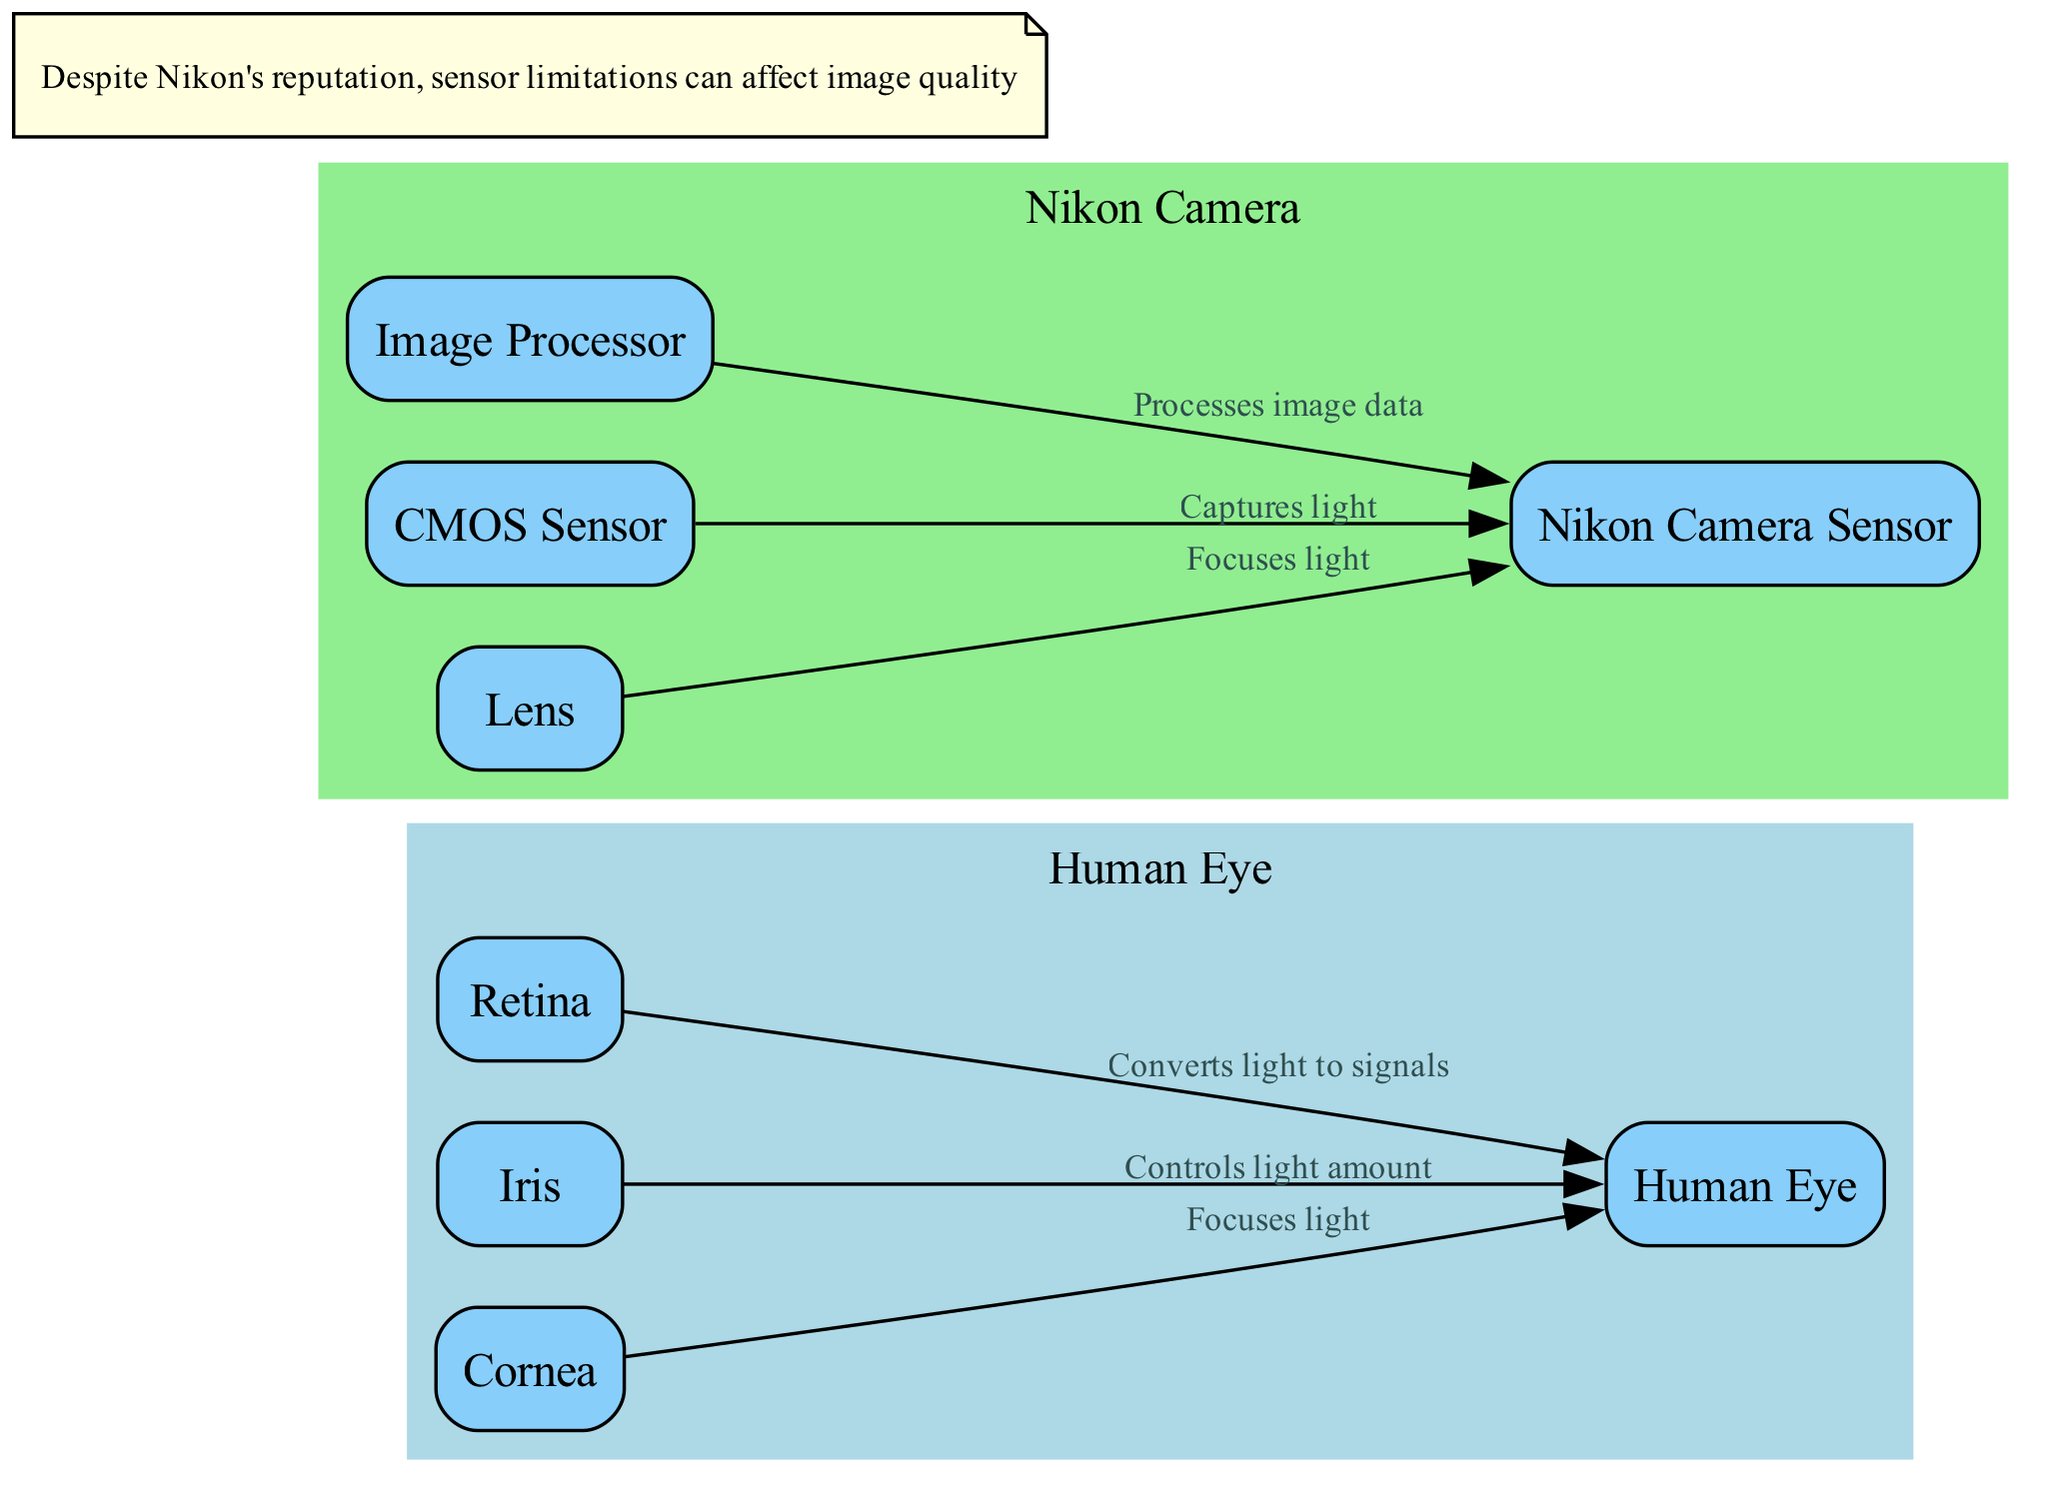What node controls the amount of light entering the eye? The diagram indicates that the "Iris" node is responsible for controlling the amount of light that enters the eye. This can be found by examining the direct connection from the "Iris" to the "Human Eye" node, where the edge explicitly states its function.
Answer: Iris How many nodes represent parts of the Nikon camera system? By counting the nodes listed within the "Nikon Camera" subgraph, we find that there are four distinct nodes: "Nikon Camera Sensor," "Lens," "CMOS Sensor," and "Image Processor." Therefore, the total number of camera system parts represented is four.
Answer: 4 What is the role of the Retina in the human eye? The diagram illustrates that the "Retina" converts light to signals. This is evident from the edge connecting the "Retina" to the "Human Eye," where the label clearly describes this function.
Answer: Converts light to signals Which part focuses light for both the eye and camera? The explanation requires identifying both "Cornea" for the eye and "Lens" for the camera, which serve the same purpose of focusing light. However, since the question asks for a singular part, we see that "Lens" in the camera performs the focusing function in a similar way.
Answer: Lens What is the connection between the CMOS Sensor and the Nikon Camera? The diagram shows that the "CMOS Sensor" captures light, as depicted by the edge from "CMOS Sensor" to "Nikon Camera" with the label "Captures light." This directly indicates the function fulfilled by the CMOS Sensor in the Nikon Camera.
Answer: Captures light Which node in the diagram handles image processing for the camera? According to the diagram, the "Image Processor" node is responsible for processing image data. This is indicated by the edge connecting the "Image Processor" to "Nikon Camera," explicitly labeling its function.
Answer: Image Processor How does the eye focus light? The diagram details that the "Cornea" focuses light, as shown by the edge leading from "Cornea" to "Human Eye" with the label "Focuses light." It is through this relationship that we determine the focusing role played by the cornea in light capture.
Answer: Focuses light What are the two light-controlling components mentioned in the diagram? By analyzing the diagram, we can point out that the components controlling light are the "Iris" in the human eye and the "Lens" in the camera. The edges show their respective functions connected to the eye and camera nodes.
Answer: Iris and Lens 